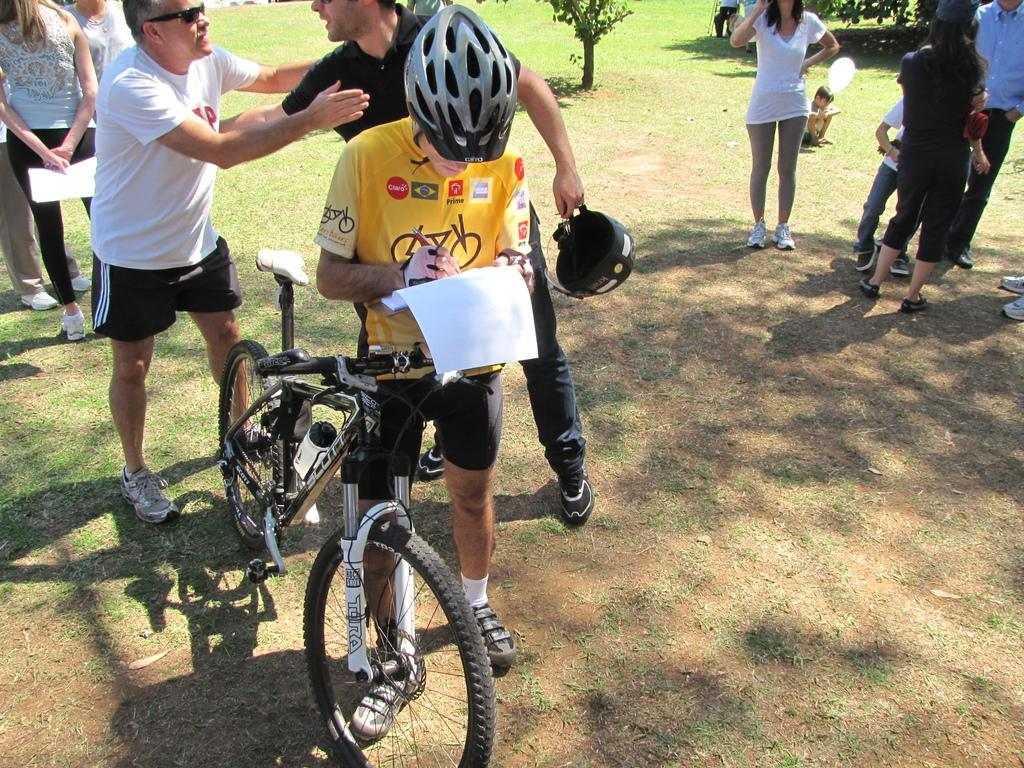How many people are in the image? There are people in the image. What type of terrain is visible in the image? There is grass and trees in the image. What mode of transportation is present in the image? There is a bicycle in the image. What safety gear is the man wearing in the image? The man is wearing a helmet in the image. What object is the man holding in the image? The man is holding a paper in the image. What police theory is being discussed in the image? There is no mention of police or any theories in the image. 